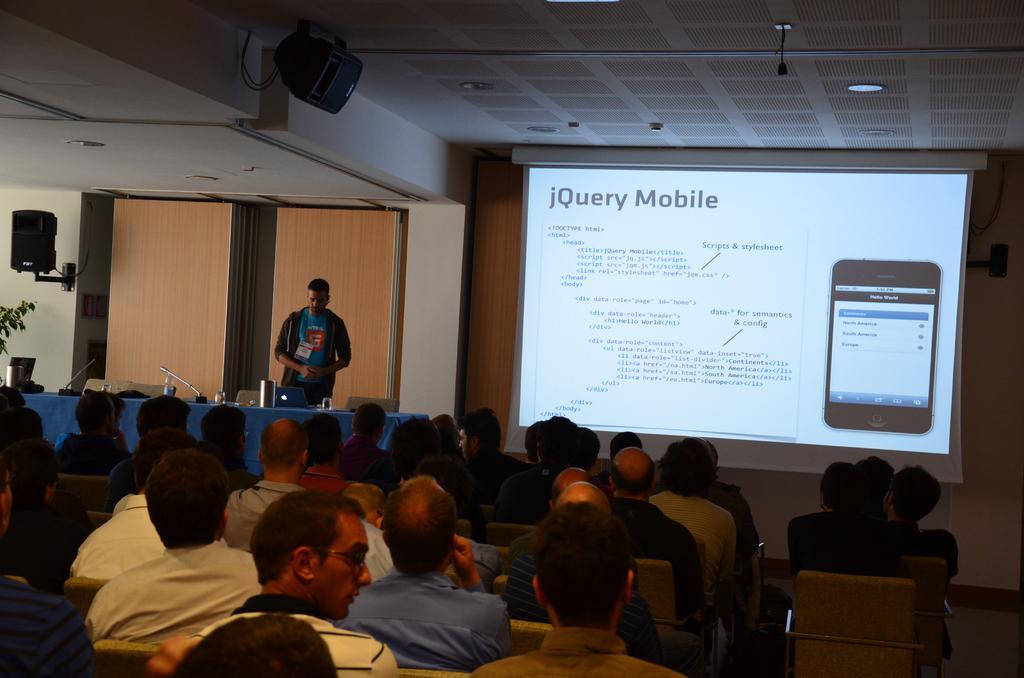Can you describe this image briefly? In this image in the front there are group of persons sitting. In the background there is a screen and on the screen there is some text and images on it. On the left side there is a person standing and in front of the person there is a table, on the table there are objects and there are empty chairs and there are speakers on the wall and there are leaves which are visible. 